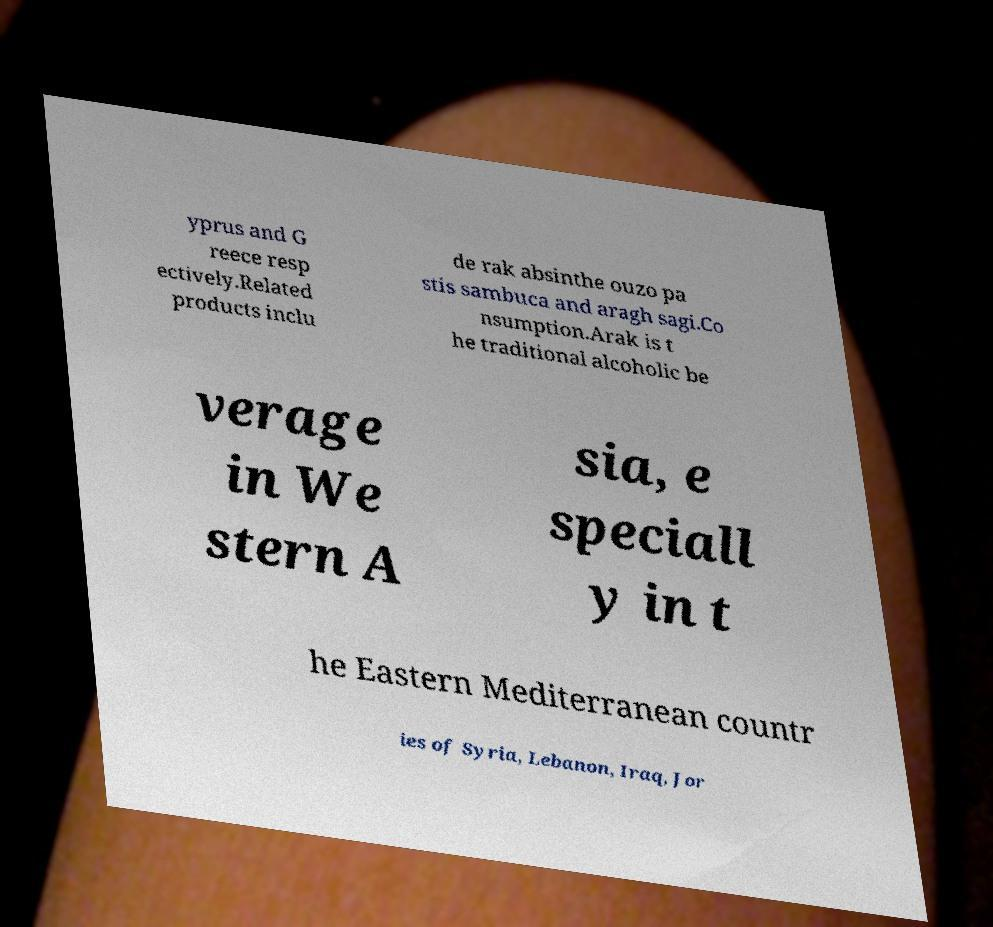What messages or text are displayed in this image? I need them in a readable, typed format. yprus and G reece resp ectively.Related products inclu de rak absinthe ouzo pa stis sambuca and aragh sagi.Co nsumption.Arak is t he traditional alcoholic be verage in We stern A sia, e speciall y in t he Eastern Mediterranean countr ies of Syria, Lebanon, Iraq, Jor 